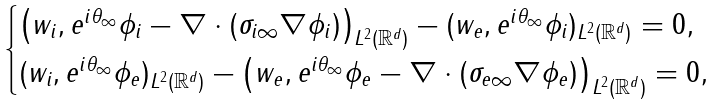<formula> <loc_0><loc_0><loc_500><loc_500>\begin{cases} \left ( w _ { i } , e ^ { i \theta _ { \infty } } \phi _ { i } - \nabla \cdot ( \sigma _ { i \infty } \nabla \phi _ { i } ) \right ) _ { L ^ { 2 } ( \mathbb { R } ^ { d } ) } - ( w _ { e } , e ^ { i \theta _ { \infty } } \phi _ { i } ) _ { L ^ { 2 } ( \mathbb { R } ^ { d } ) } = 0 , \\ ( w _ { i } , e ^ { i \theta _ { \infty } } \phi _ { e } ) _ { L ^ { 2 } ( \mathbb { R } ^ { d } ) } - \left ( w _ { e } , e ^ { i \theta _ { \infty } } \phi _ { e } - \nabla \cdot ( \sigma _ { e \infty } \nabla \phi _ { e } ) \right ) _ { L ^ { 2 } ( \mathbb { R } ^ { d } ) } = 0 , \end{cases}</formula> 